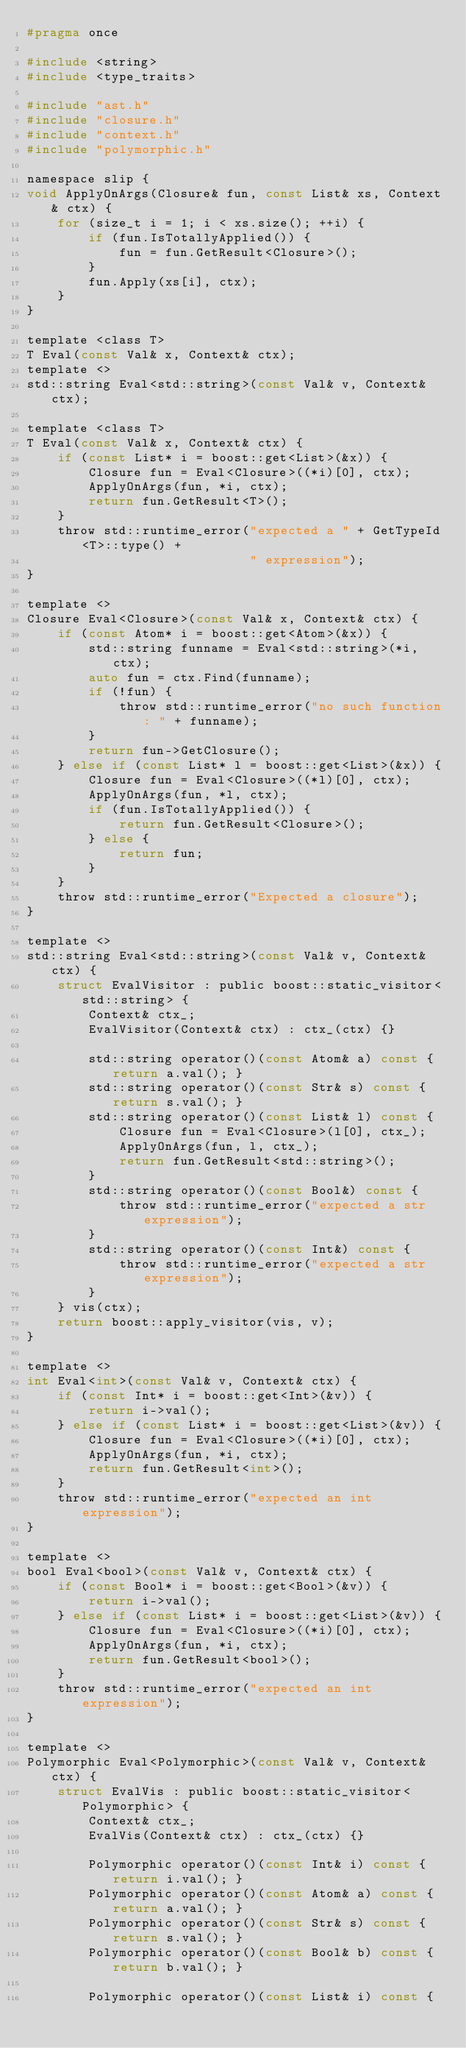<code> <loc_0><loc_0><loc_500><loc_500><_C_>#pragma once

#include <string>
#include <type_traits>

#include "ast.h"
#include "closure.h"
#include "context.h"
#include "polymorphic.h"

namespace slip {
void ApplyOnArgs(Closure& fun, const List& xs, Context& ctx) {
    for (size_t i = 1; i < xs.size(); ++i) {
        if (fun.IsTotallyApplied()) {
            fun = fun.GetResult<Closure>();
        }
        fun.Apply(xs[i], ctx);
    }
}

template <class T>
T Eval(const Val& x, Context& ctx);
template <>
std::string Eval<std::string>(const Val& v, Context& ctx);

template <class T>
T Eval(const Val& x, Context& ctx) {
    if (const List* i = boost::get<List>(&x)) {
        Closure fun = Eval<Closure>((*i)[0], ctx);
        ApplyOnArgs(fun, *i, ctx);
        return fun.GetResult<T>();
    }
    throw std::runtime_error("expected a " + GetTypeId<T>::type() +
                             " expression");
}

template <>
Closure Eval<Closure>(const Val& x, Context& ctx) {
    if (const Atom* i = boost::get<Atom>(&x)) {
        std::string funname = Eval<std::string>(*i, ctx);
        auto fun = ctx.Find(funname);
        if (!fun) {
            throw std::runtime_error("no such function: " + funname);
        }
        return fun->GetClosure();
    } else if (const List* l = boost::get<List>(&x)) {
        Closure fun = Eval<Closure>((*l)[0], ctx);
        ApplyOnArgs(fun, *l, ctx);
        if (fun.IsTotallyApplied()) {
            return fun.GetResult<Closure>();
        } else {
            return fun;
        }
    }
    throw std::runtime_error("Expected a closure");
}

template <>
std::string Eval<std::string>(const Val& v, Context& ctx) {
    struct EvalVisitor : public boost::static_visitor<std::string> {
        Context& ctx_;
        EvalVisitor(Context& ctx) : ctx_(ctx) {}

        std::string operator()(const Atom& a) const { return a.val(); }
        std::string operator()(const Str& s) const { return s.val(); }
        std::string operator()(const List& l) const {
            Closure fun = Eval<Closure>(l[0], ctx_);
            ApplyOnArgs(fun, l, ctx_);
            return fun.GetResult<std::string>();
        }
        std::string operator()(const Bool&) const {
            throw std::runtime_error("expected a str expression");
        }
        std::string operator()(const Int&) const {
            throw std::runtime_error("expected a str expression");
        }
    } vis(ctx);
    return boost::apply_visitor(vis, v);
}

template <>
int Eval<int>(const Val& v, Context& ctx) {
    if (const Int* i = boost::get<Int>(&v)) {
        return i->val();
    } else if (const List* i = boost::get<List>(&v)) {
        Closure fun = Eval<Closure>((*i)[0], ctx);
        ApplyOnArgs(fun, *i, ctx);
        return fun.GetResult<int>();
    }
    throw std::runtime_error("expected an int expression");
}

template <>
bool Eval<bool>(const Val& v, Context& ctx) {
    if (const Bool* i = boost::get<Bool>(&v)) {
        return i->val();
    } else if (const List* i = boost::get<List>(&v)) {
        Closure fun = Eval<Closure>((*i)[0], ctx);
        ApplyOnArgs(fun, *i, ctx);
        return fun.GetResult<bool>();
    }
    throw std::runtime_error("expected an int expression");
}

template <>
Polymorphic Eval<Polymorphic>(const Val& v, Context& ctx) {
    struct EvalVis : public boost::static_visitor<Polymorphic> {
        Context& ctx_;
        EvalVis(Context& ctx) : ctx_(ctx) {}

        Polymorphic operator()(const Int& i) const { return i.val(); }
        Polymorphic operator()(const Atom& a) const { return a.val(); }
        Polymorphic operator()(const Str& s) const { return s.val(); }
        Polymorphic operator()(const Bool& b) const { return b.val(); }

        Polymorphic operator()(const List& i) const {</code> 